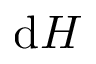Convert formula to latex. <formula><loc_0><loc_0><loc_500><loc_500>d H</formula> 